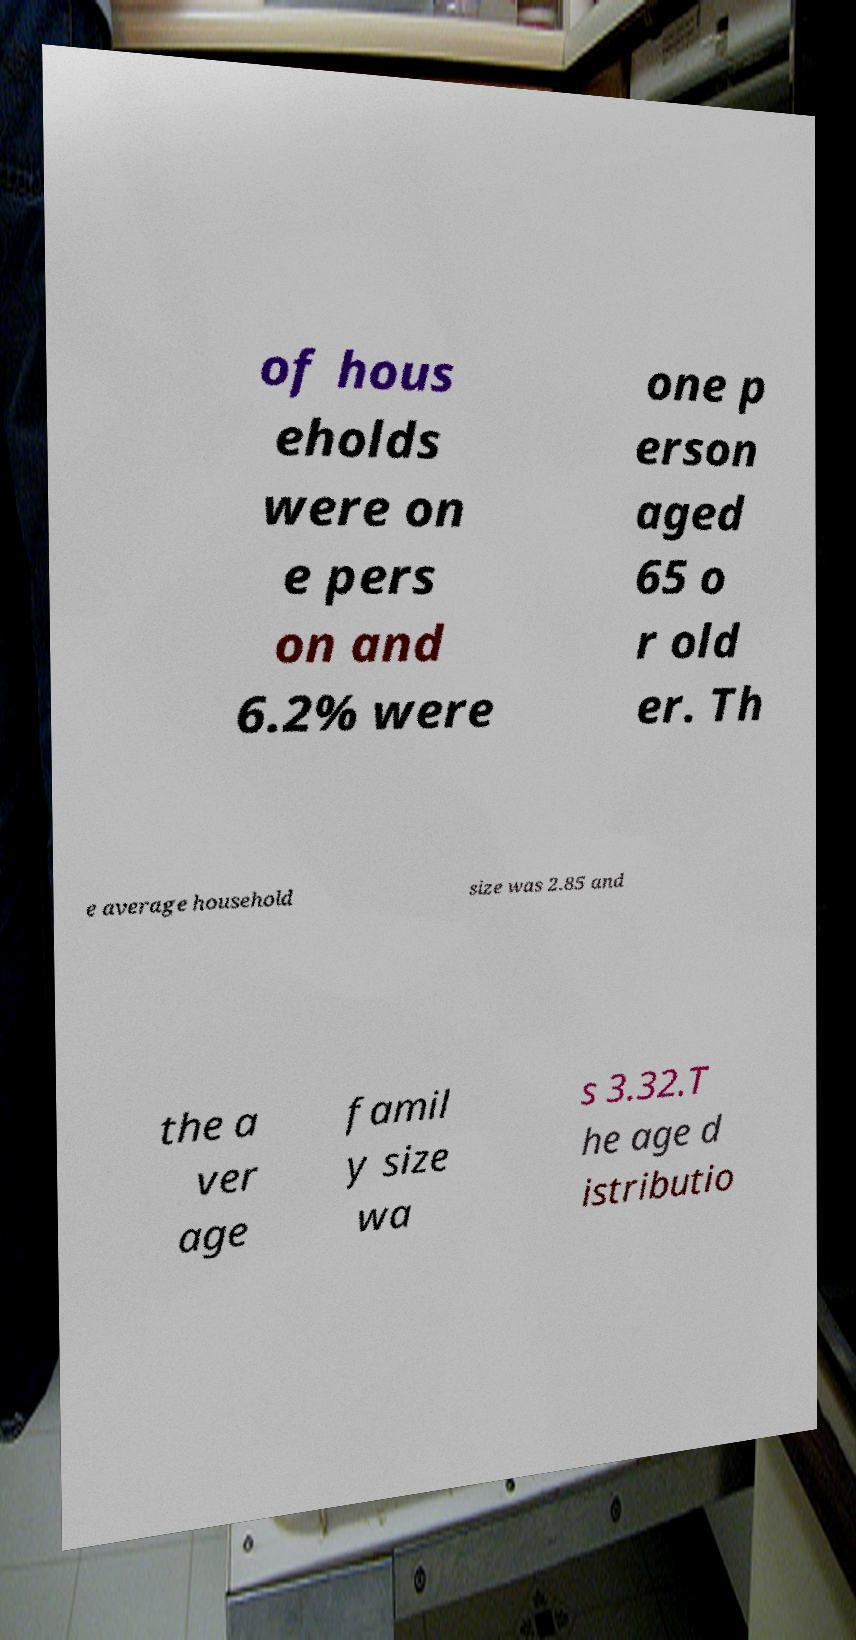Can you read and provide the text displayed in the image?This photo seems to have some interesting text. Can you extract and type it out for me? of hous eholds were on e pers on and 6.2% were one p erson aged 65 o r old er. Th e average household size was 2.85 and the a ver age famil y size wa s 3.32.T he age d istributio 